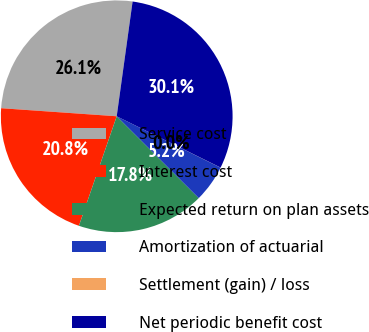Convert chart. <chart><loc_0><loc_0><loc_500><loc_500><pie_chart><fcel>Service cost<fcel>Interest cost<fcel>Expected return on plan assets<fcel>Amortization of actuarial<fcel>Settlement (gain) / loss<fcel>Net periodic benefit cost<nl><fcel>26.08%<fcel>20.82%<fcel>17.81%<fcel>5.17%<fcel>0.01%<fcel>30.11%<nl></chart> 